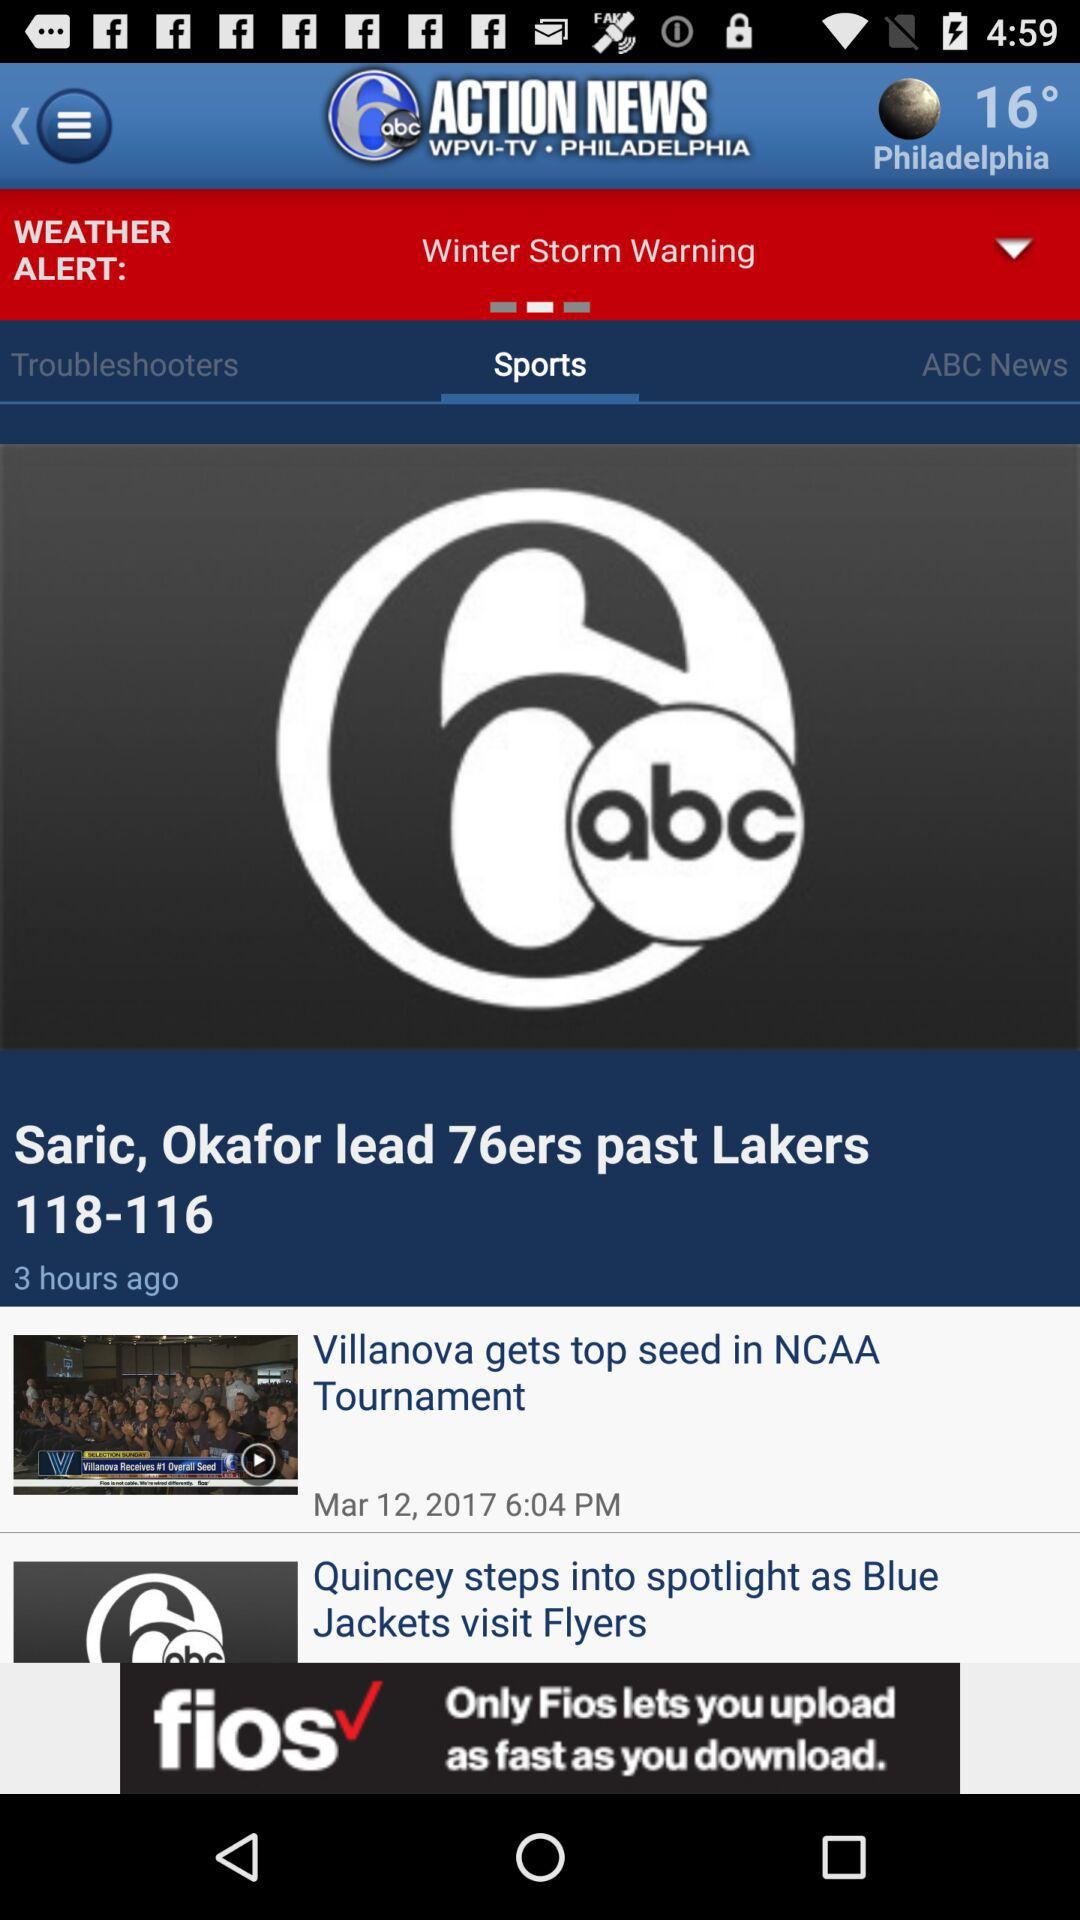What is the name of the news channel? The name of the news channel is "6 abc ACTION NEWS". 